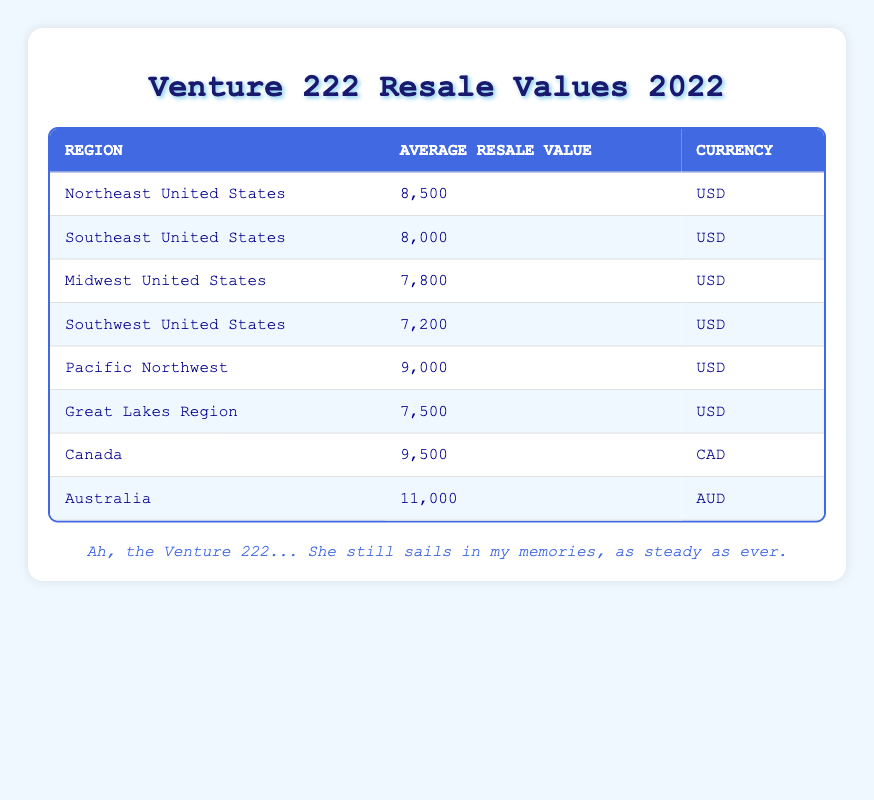What is the average resale value of the Venture 222 in the Northeast United States? According to the table, the average resale value for the Northeast United States is listed directly. The value is 8,500.
Answer: 8,500 Which region has the highest average resale value for the Venture 222? Looking through the table, I identify the regions and their corresponding resale values. Canada is noted to have the highest average resale value at 9,500 CAD.
Answer: Canada What is the average resale value of the Venture 222 across all regions listed in USD? To calculate the overall average, I sum the average resale values in USD: (8,500 + 8,000 + 7,800 + 7,200 + 9,000 + 7,500) = 49,000. There are six entries in USD, so I divide 49,000 by 6, yielding an average of approximately 8,166.67.
Answer: 8,166.67 Is the average resale value of the Venture 222 higher in Canada than in the Pacific Northwest? From the table, I see the average resale value in Canada is 9,500 CAD and in the Pacific Northwest, it is 9,000 USD. To compare these values effectively, I recognize that they are in different currencies. However, in local currency terms, Canada has a higher resale value.
Answer: Yes What is the difference in average resale value between the highest and lowest regions in the United States? I identify the highest average resale value in the table (Northeast United States at 8,500) and the lowest (Southwest United States at 7,200). The difference is calculated as 8,500 - 7,200 = 1,300.
Answer: 1,300 